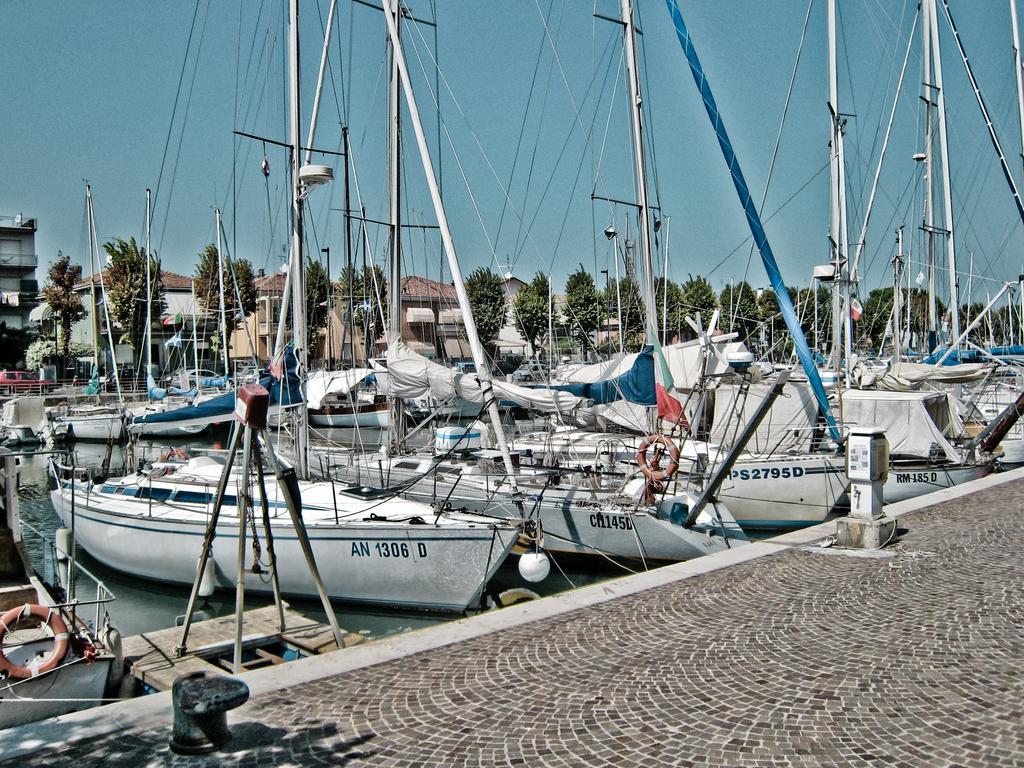Could you give a brief overview of what you see in this image? In this image we can see many watercraft. There is some text on the watercraft. There are many trees in the image. There are few vehicles at the left side of the image. We can see the sky in the image. There are few barriers at the left side of the image. We can see few tubes on the watercraft. We can see the lake in the image. There are many buildings in the image. 